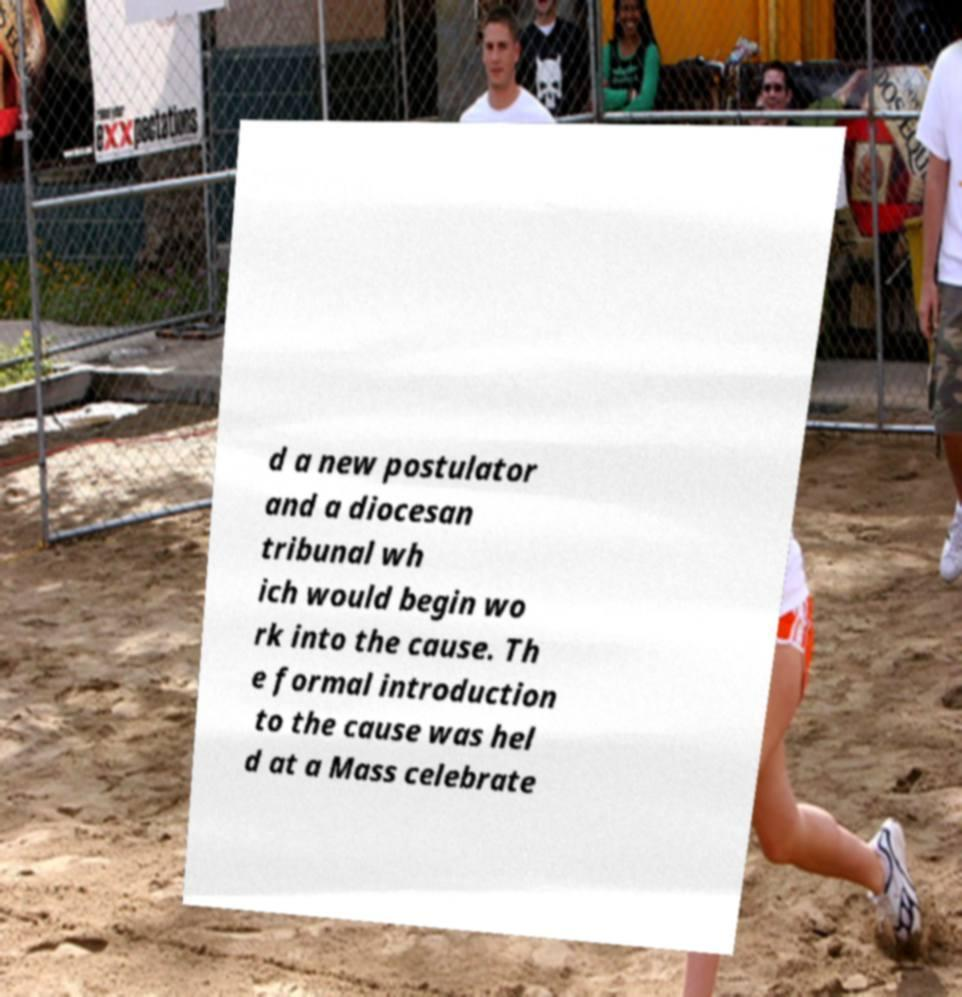Could you assist in decoding the text presented in this image and type it out clearly? d a new postulator and a diocesan tribunal wh ich would begin wo rk into the cause. Th e formal introduction to the cause was hel d at a Mass celebrate 